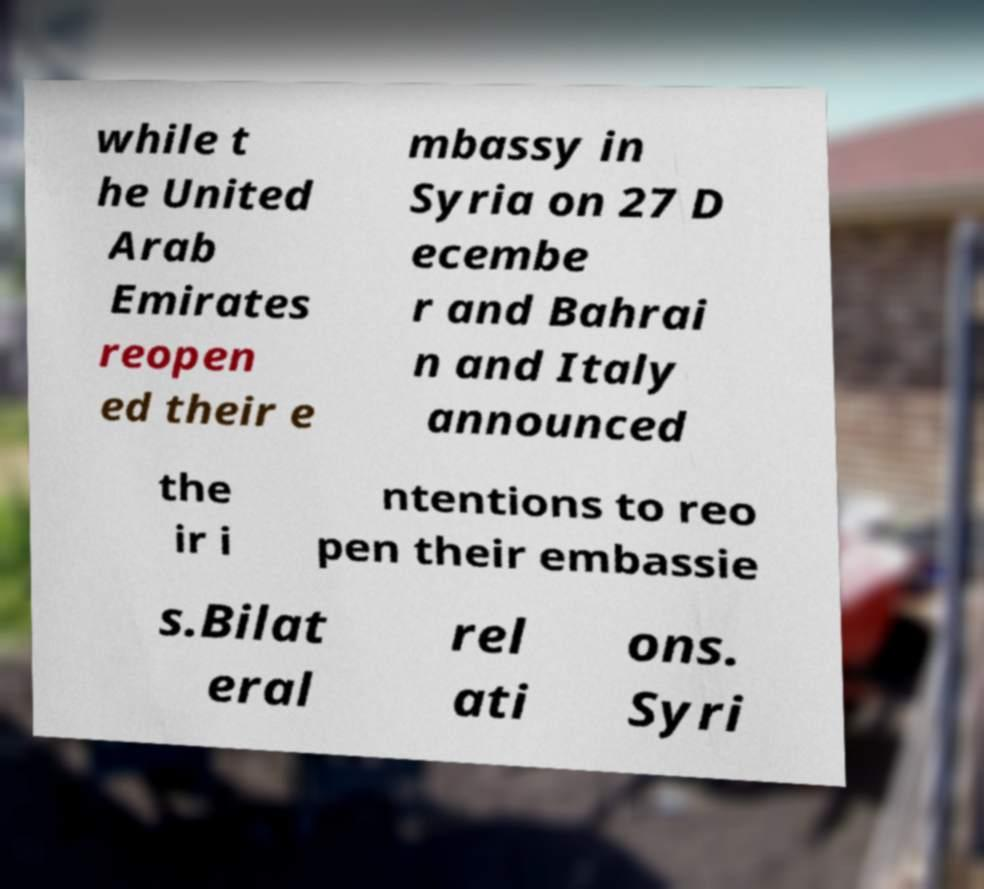Can you accurately transcribe the text from the provided image for me? while t he United Arab Emirates reopen ed their e mbassy in Syria on 27 D ecembe r and Bahrai n and Italy announced the ir i ntentions to reo pen their embassie s.Bilat eral rel ati ons. Syri 